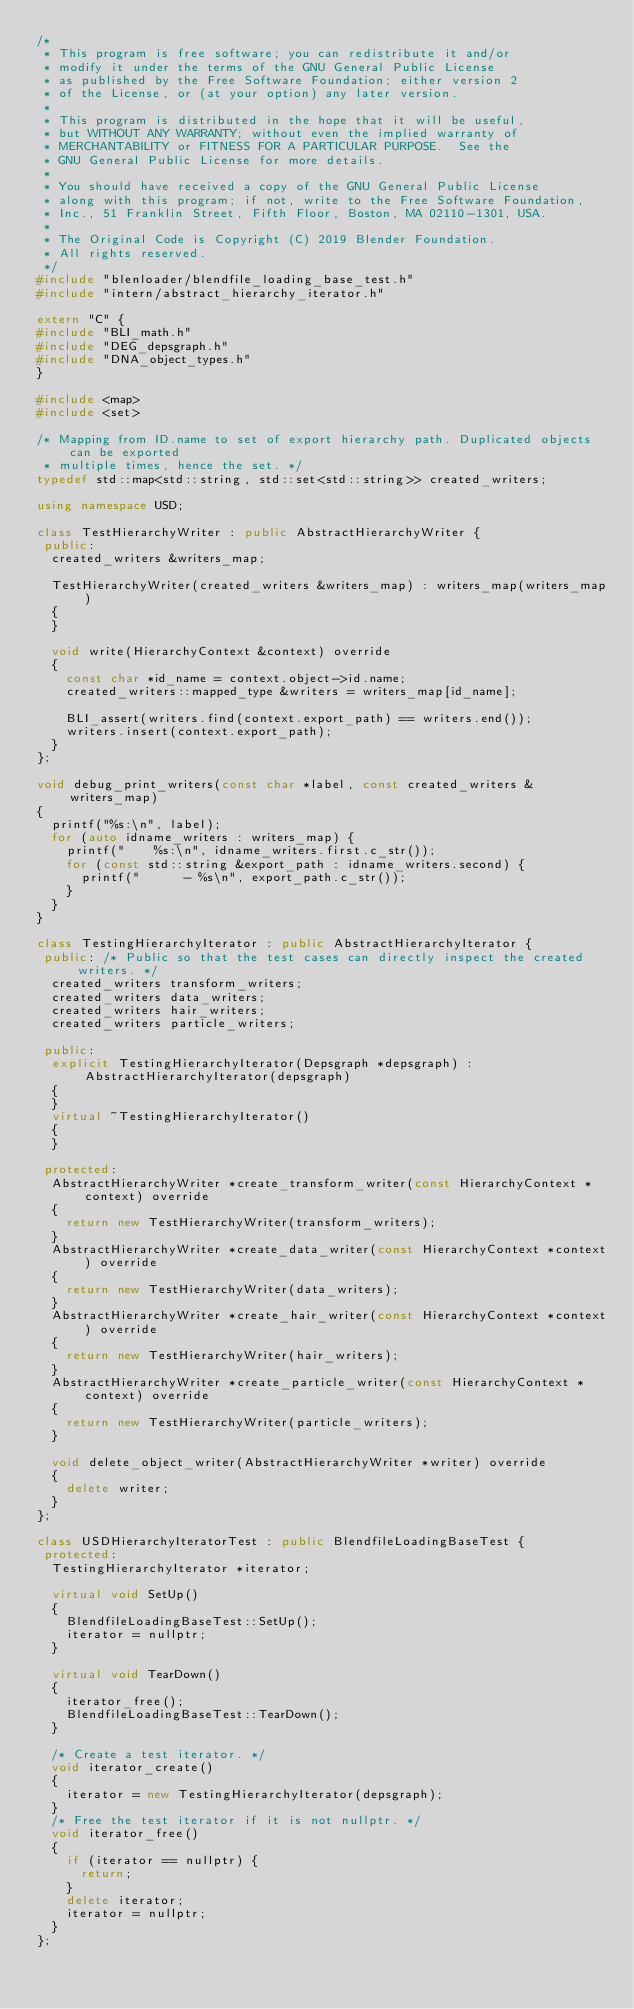<code> <loc_0><loc_0><loc_500><loc_500><_C++_>/*
 * This program is free software; you can redistribute it and/or
 * modify it under the terms of the GNU General Public License
 * as published by the Free Software Foundation; either version 2
 * of the License, or (at your option) any later version.
 *
 * This program is distributed in the hope that it will be useful,
 * but WITHOUT ANY WARRANTY; without even the implied warranty of
 * MERCHANTABILITY or FITNESS FOR A PARTICULAR PURPOSE.  See the
 * GNU General Public License for more details.
 *
 * You should have received a copy of the GNU General Public License
 * along with this program; if not, write to the Free Software Foundation,
 * Inc., 51 Franklin Street, Fifth Floor, Boston, MA 02110-1301, USA.
 *
 * The Original Code is Copyright (C) 2019 Blender Foundation.
 * All rights reserved.
 */
#include "blenloader/blendfile_loading_base_test.h"
#include "intern/abstract_hierarchy_iterator.h"

extern "C" {
#include "BLI_math.h"
#include "DEG_depsgraph.h"
#include "DNA_object_types.h"
}

#include <map>
#include <set>

/* Mapping from ID.name to set of export hierarchy path. Duplicated objects can be exported
 * multiple times, hence the set. */
typedef std::map<std::string, std::set<std::string>> created_writers;

using namespace USD;

class TestHierarchyWriter : public AbstractHierarchyWriter {
 public:
  created_writers &writers_map;

  TestHierarchyWriter(created_writers &writers_map) : writers_map(writers_map)
  {
  }

  void write(HierarchyContext &context) override
  {
    const char *id_name = context.object->id.name;
    created_writers::mapped_type &writers = writers_map[id_name];

    BLI_assert(writers.find(context.export_path) == writers.end());
    writers.insert(context.export_path);
  }
};

void debug_print_writers(const char *label, const created_writers &writers_map)
{
  printf("%s:\n", label);
  for (auto idname_writers : writers_map) {
    printf("    %s:\n", idname_writers.first.c_str());
    for (const std::string &export_path : idname_writers.second) {
      printf("      - %s\n", export_path.c_str());
    }
  }
}

class TestingHierarchyIterator : public AbstractHierarchyIterator {
 public: /* Public so that the test cases can directly inspect the created writers. */
  created_writers transform_writers;
  created_writers data_writers;
  created_writers hair_writers;
  created_writers particle_writers;

 public:
  explicit TestingHierarchyIterator(Depsgraph *depsgraph) : AbstractHierarchyIterator(depsgraph)
  {
  }
  virtual ~TestingHierarchyIterator()
  {
  }

 protected:
  AbstractHierarchyWriter *create_transform_writer(const HierarchyContext *context) override
  {
    return new TestHierarchyWriter(transform_writers);
  }
  AbstractHierarchyWriter *create_data_writer(const HierarchyContext *context) override
  {
    return new TestHierarchyWriter(data_writers);
  }
  AbstractHierarchyWriter *create_hair_writer(const HierarchyContext *context) override
  {
    return new TestHierarchyWriter(hair_writers);
  }
  AbstractHierarchyWriter *create_particle_writer(const HierarchyContext *context) override
  {
    return new TestHierarchyWriter(particle_writers);
  }

  void delete_object_writer(AbstractHierarchyWriter *writer) override
  {
    delete writer;
  }
};

class USDHierarchyIteratorTest : public BlendfileLoadingBaseTest {
 protected:
  TestingHierarchyIterator *iterator;

  virtual void SetUp()
  {
    BlendfileLoadingBaseTest::SetUp();
    iterator = nullptr;
  }

  virtual void TearDown()
  {
    iterator_free();
    BlendfileLoadingBaseTest::TearDown();
  }

  /* Create a test iterator. */
  void iterator_create()
  {
    iterator = new TestingHierarchyIterator(depsgraph);
  }
  /* Free the test iterator if it is not nullptr. */
  void iterator_free()
  {
    if (iterator == nullptr) {
      return;
    }
    delete iterator;
    iterator = nullptr;
  }
};
</code> 